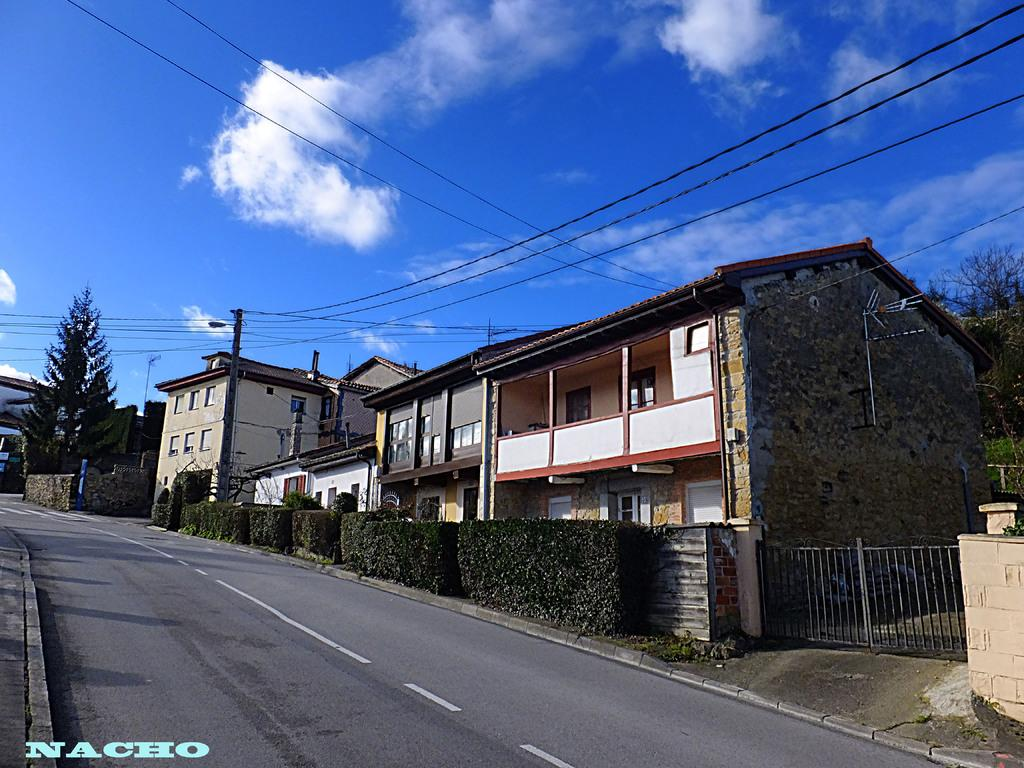<image>
Give a short and clear explanation of the subsequent image. Building under a cloudy sky and the word NACHO near the bottom. 